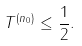Convert formula to latex. <formula><loc_0><loc_0><loc_500><loc_500>\| T ^ { ( n _ { 0 } ) } \| \leq \frac { 1 } { 2 } .</formula> 